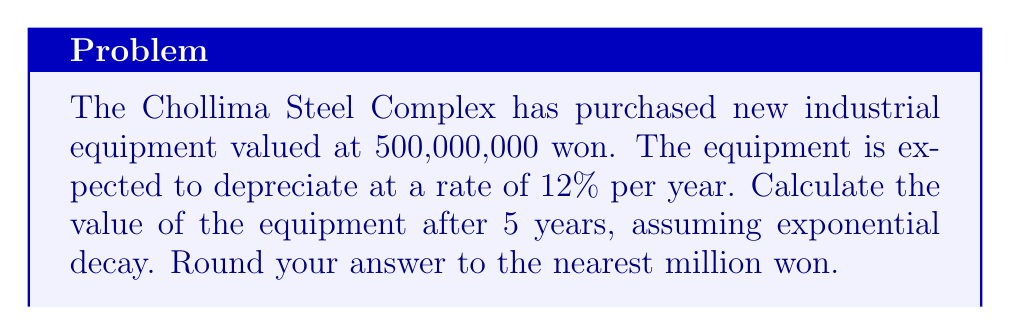Provide a solution to this math problem. To solve this problem, we'll use the exponential decay formula:

$$A = P(1-r)^t$$

Where:
$A$ = Final amount
$P$ = Initial principal value
$r$ = Rate of depreciation (as a decimal)
$t$ = Time in years

Given:
$P = 500,000,000$ won
$r = 12\% = 0.12$
$t = 5$ years

Let's substitute these values into the formula:

$$A = 500,000,000(1-0.12)^5$$

Simplify:
$$A = 500,000,000(0.88)^5$$

Calculate the power:
$$A = 500,000,000 \times 0.52656$$

Multiply:
$$A = 263,280,000$$

Rounding to the nearest million:
$$A \approx 263,000,000\text{ won}$$
Answer: 263,000,000 won 